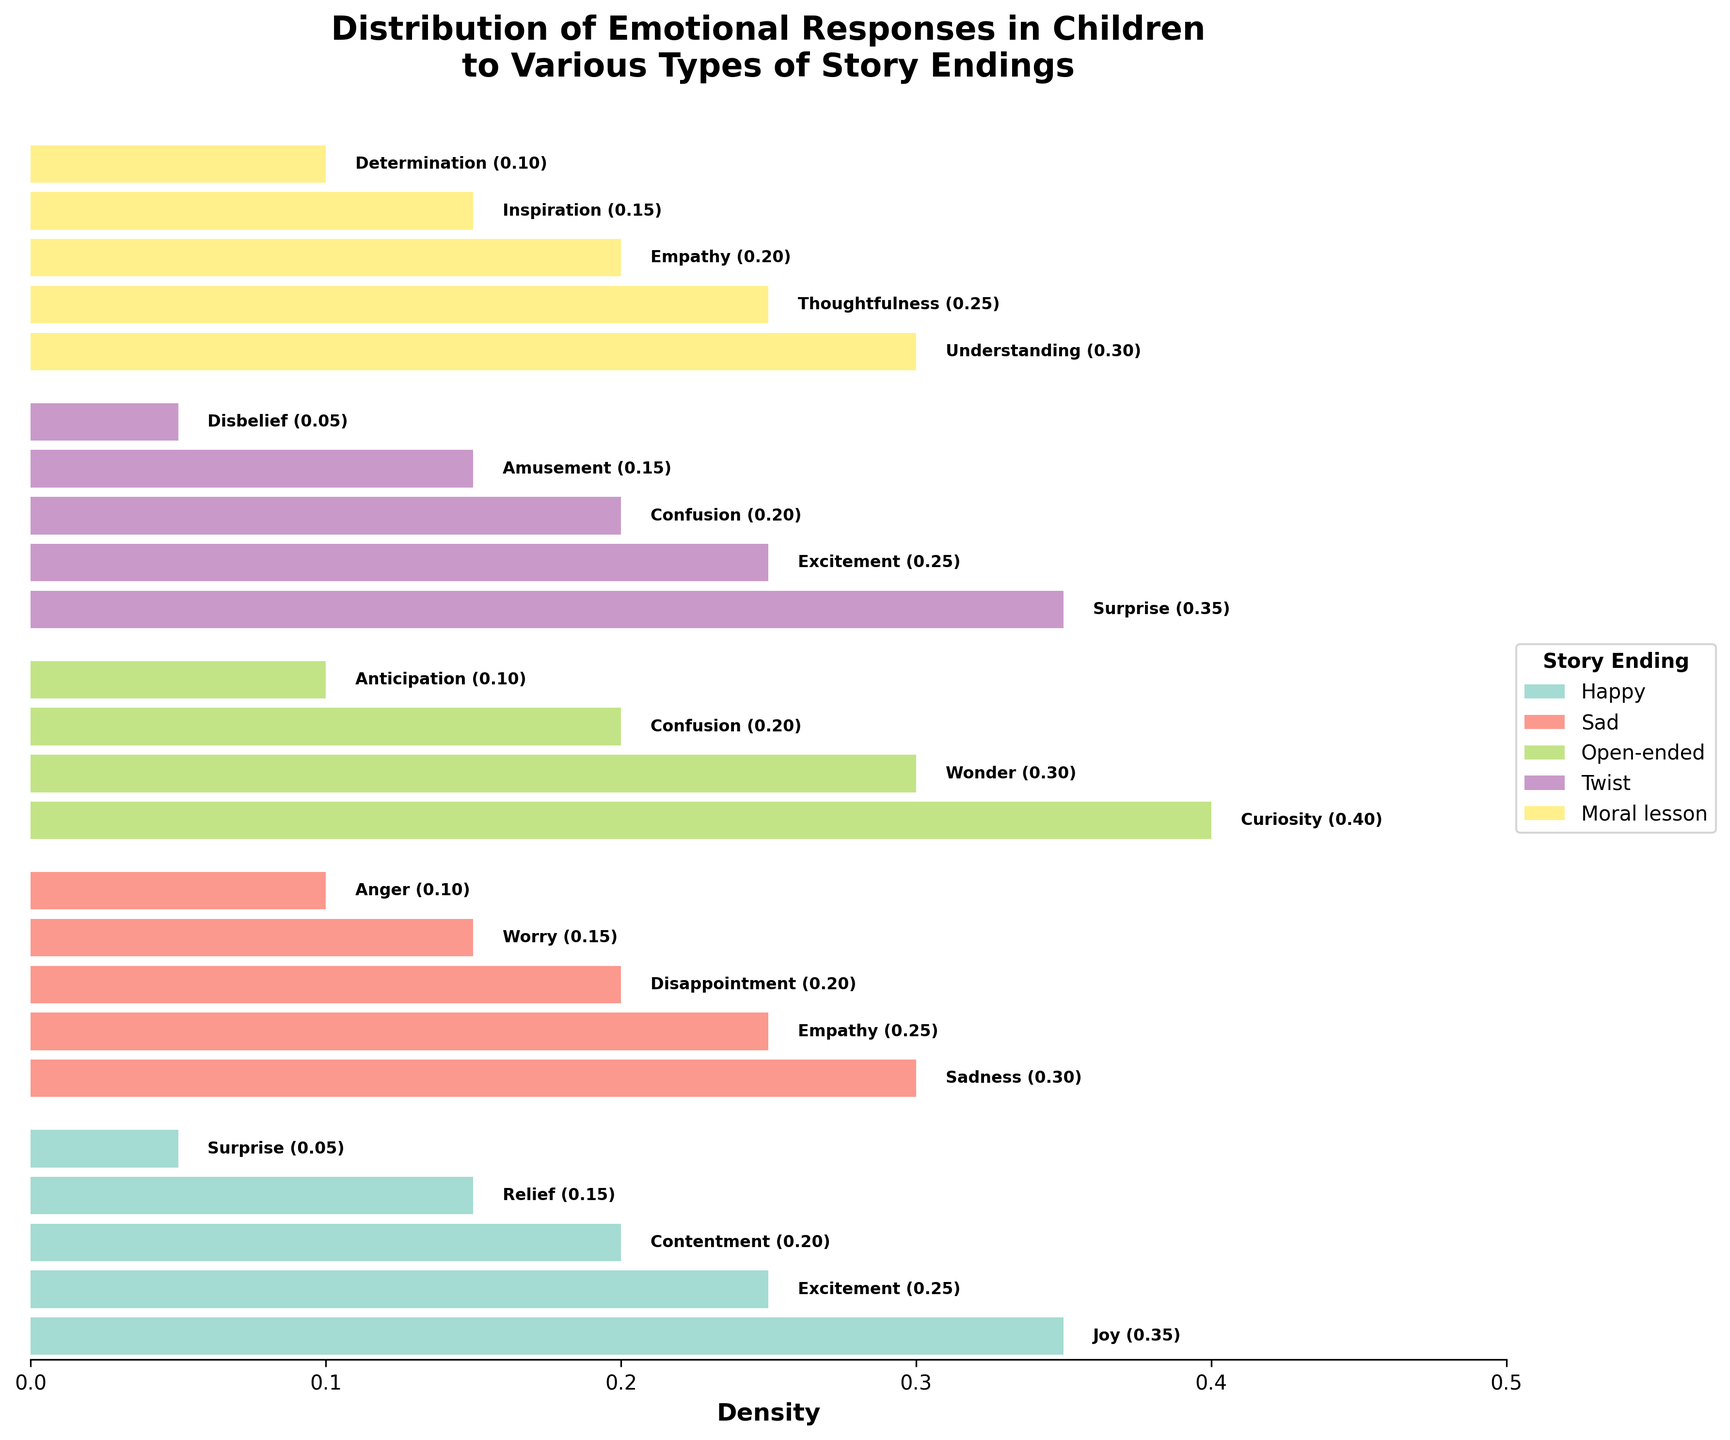What is the most common emotional response to happy story endings? Based on the density values for happy story endings, 'Joy' has the highest density of 0.35, making it the most common emotional response.
Answer: Joy Which story ending type generated the highest density for 'Curiosity'? By looking at the densities across different story endings, 'Curiosity' has a density of 0.40 for open-ended stories, which is the highest across all types.
Answer: Open-ended What is the combined density of 'Empathy' emotional responses across all story endings? 'Empathy' appears in sad and moral lesson endings with densities of 0.25 and 0.20, respectively. Adding these together gives 0.45.
Answer: 0.45 Which emotion has the lowest density in happy story endings, and what is its value? By referring to the happy story endings, 'Surprise' has the lowest density of 0.05.
Answer: Surprise (0.05) How many different emotions are depicted in the plot for twist story endings? The plot denotes five different emotions for twist story endings: 'Surprise', 'Excitement', 'Confusion', 'Amusement', and 'Disbelief'.
Answer: Five What type of story ending results in the highest overall density for a single emotion? The highest single density in the plot is 0.40 for 'Curiosity' in open-ended story endings.
Answer: Open-ended Among the story endings, which has the least variety of emotions depicted? Each story ending lists their respective emotions, and by counting, happy, sad, twist, and moral lesson endings have five, while open-ended has four. Thus, open-ended has the least variety.
Answer: Open-ended Compare the densities of 'Anticipation' in open-ended and 'Determination' in moral lesson endings. Which is higher? 'Anticipation' in open-ended endings has a density of 0.10, the same as 'Determination' in moral lesson endings. Therefore, they are equal.
Answer: Equal Which emotion appears both in sad and moral lesson story endings and what are the respective densities? 'Empathy' can be seen in both sad (density 0.25) and moral lesson (density 0.20) endings.
Answer: Empathy (Sad: 0.25, Moral lesson: 0.20) What is the total density for 'Contentment' and 'Relief' in happy story endings? 'Contentment' and 'Relief' have densities of 0.20 and 0.15, respectively. Summing these up yields 0.35.
Answer: 0.35 